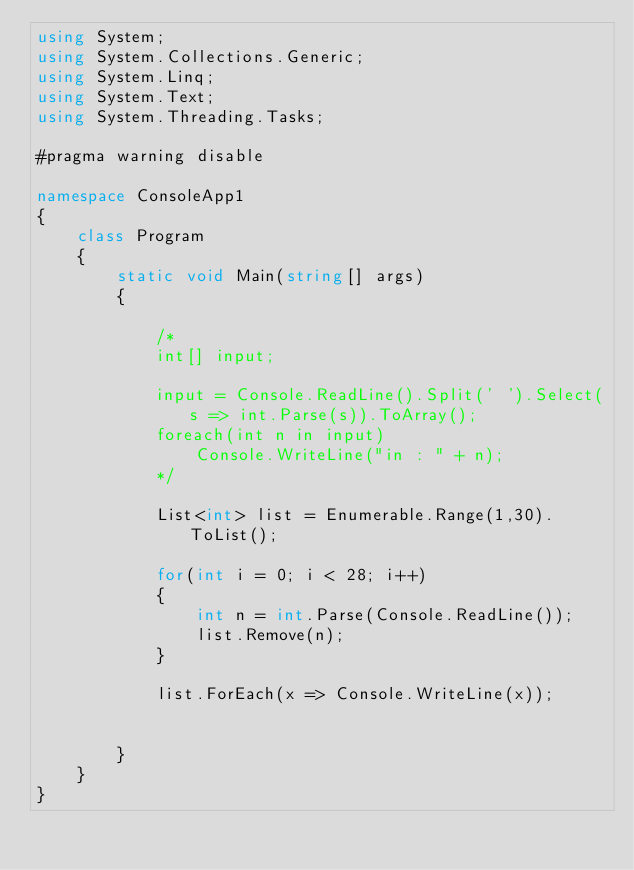<code> <loc_0><loc_0><loc_500><loc_500><_C#_>using System;
using System.Collections.Generic;
using System.Linq;
using System.Text;
using System.Threading.Tasks;

#pragma warning disable

namespace ConsoleApp1
{
    class Program
    {
        static void Main(string[] args)
        {

            /*
            int[] input;

            input = Console.ReadLine().Split(' ').Select(s => int.Parse(s)).ToArray();
            foreach(int n in input)
                Console.WriteLine("in : " + n);
            */

            List<int> list = Enumerable.Range(1,30).ToList();
            
            for(int i = 0; i < 28; i++)
            {
                int n = int.Parse(Console.ReadLine());
                list.Remove(n);
            }

            list.ForEach(x => Console.WriteLine(x));


        }
    }
}</code> 